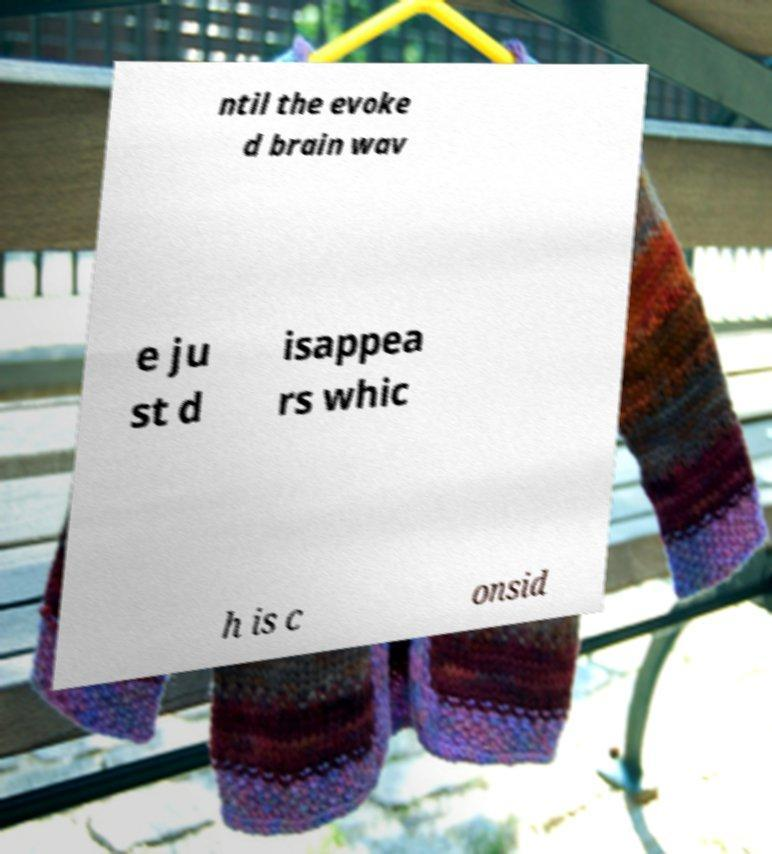Could you extract and type out the text from this image? ntil the evoke d brain wav e ju st d isappea rs whic h is c onsid 